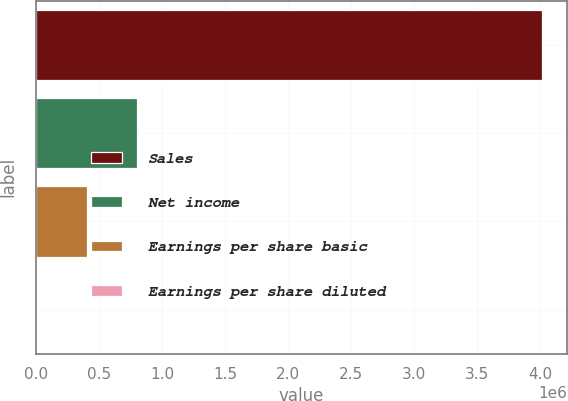Convert chart to OTSL. <chart><loc_0><loc_0><loc_500><loc_500><bar_chart><fcel>Sales<fcel>Net income<fcel>Earnings per share basic<fcel>Earnings per share diluted<nl><fcel>4.01203e+06<fcel>802411<fcel>401209<fcel>6.37<nl></chart> 